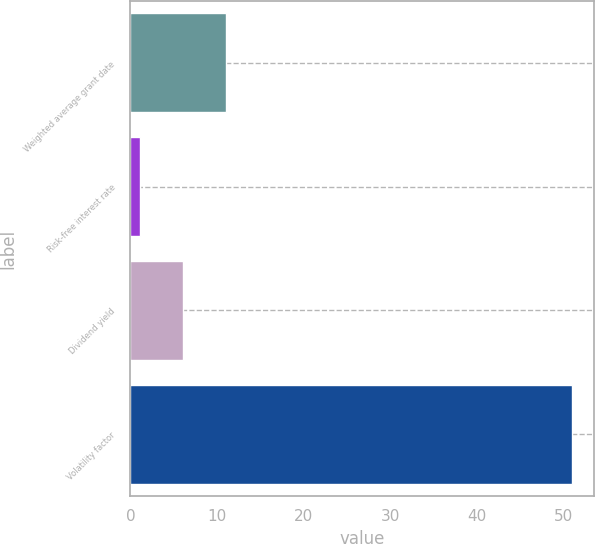Convert chart to OTSL. <chart><loc_0><loc_0><loc_500><loc_500><bar_chart><fcel>Weighted average grant date<fcel>Risk-free interest rate<fcel>Dividend yield<fcel>Volatility factor<nl><fcel>11.07<fcel>1.09<fcel>6.08<fcel>50.97<nl></chart> 